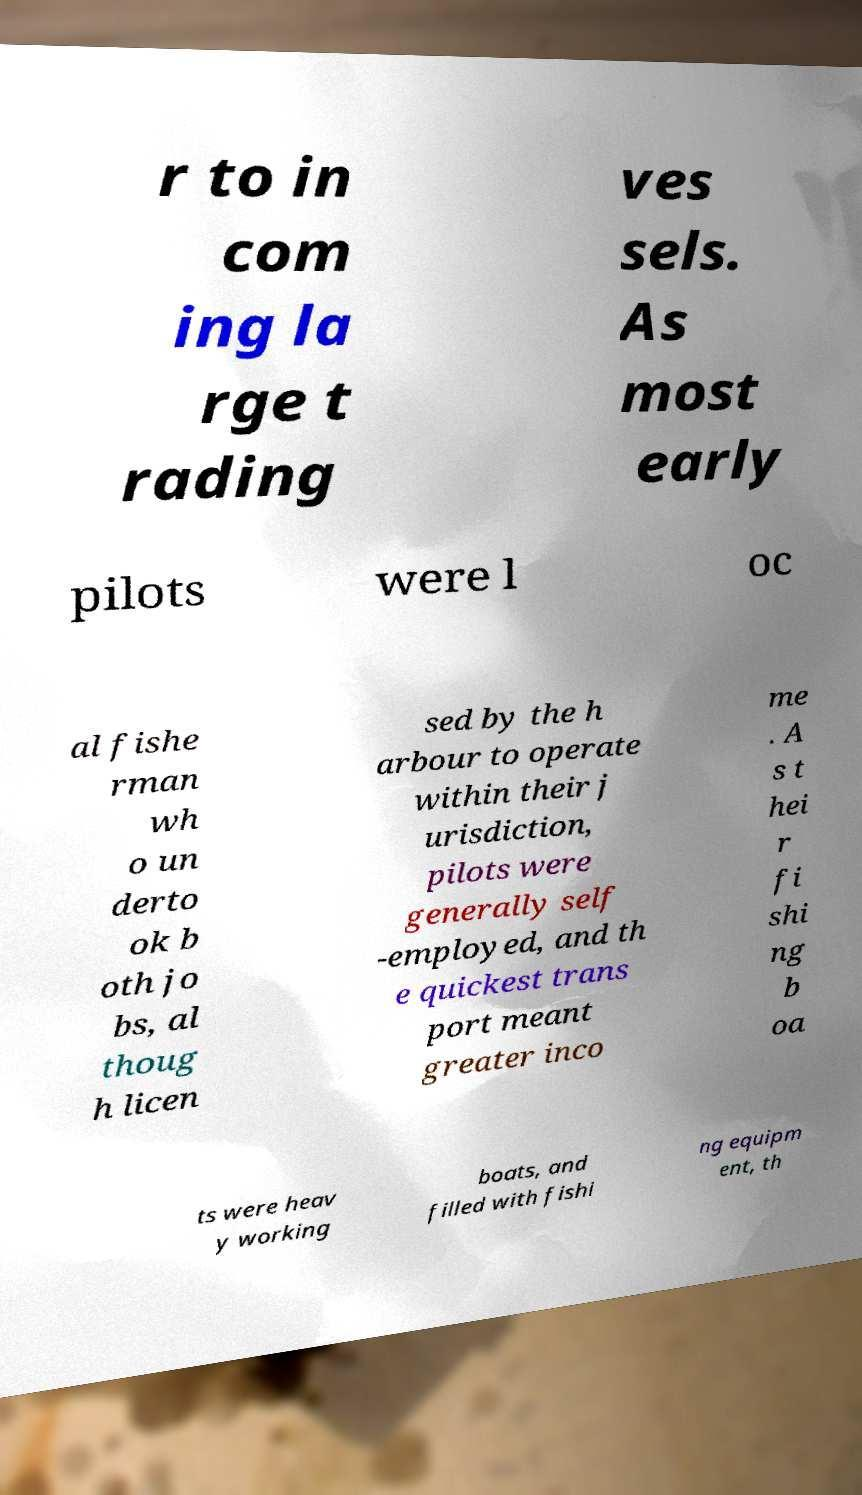What messages or text are displayed in this image? I need them in a readable, typed format. r to in com ing la rge t rading ves sels. As most early pilots were l oc al fishe rman wh o un derto ok b oth jo bs, al thoug h licen sed by the h arbour to operate within their j urisdiction, pilots were generally self -employed, and th e quickest trans port meant greater inco me . A s t hei r fi shi ng b oa ts were heav y working boats, and filled with fishi ng equipm ent, th 